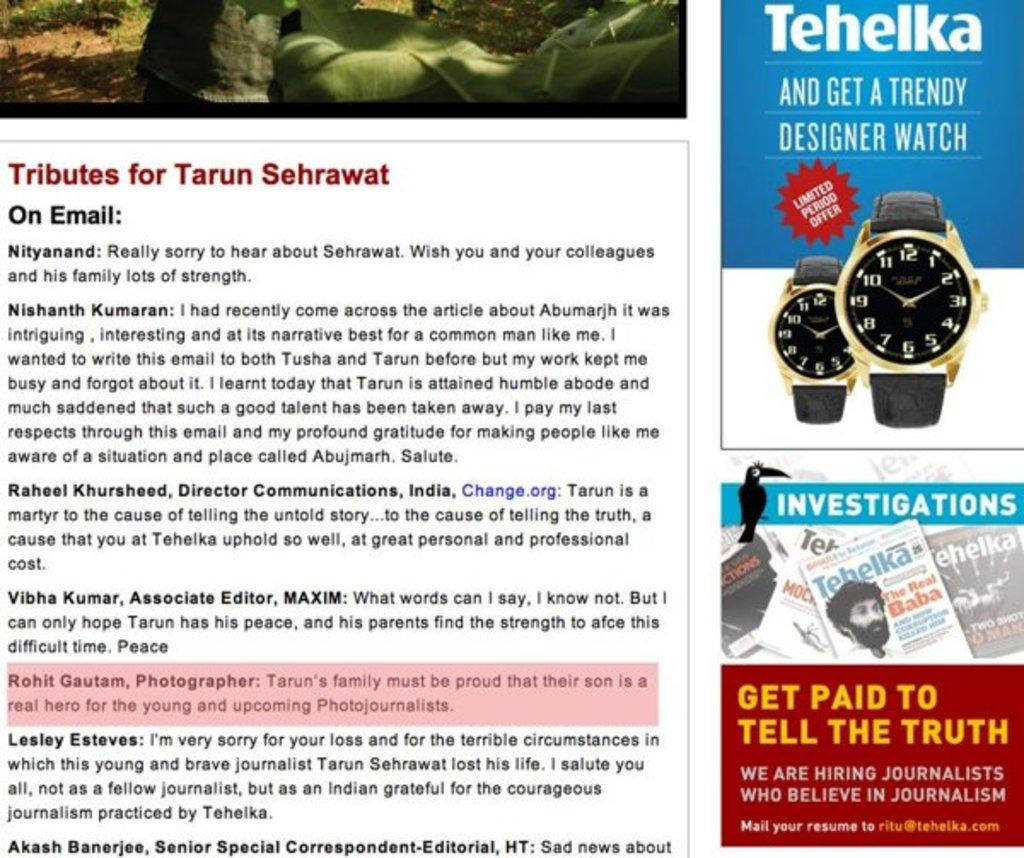<image>
Write a terse but informative summary of the picture. The title of the piece shown is called Tributes for Tarun Sehrawat 